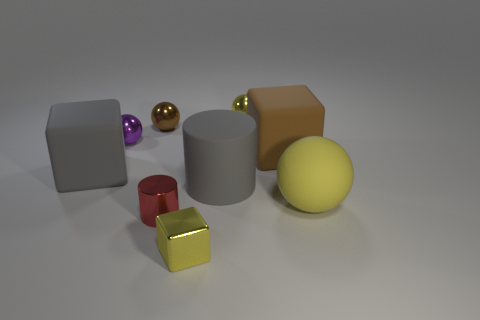Are there any big brown objects left of the small brown shiny ball?
Make the answer very short. No. There is a brown shiny object; what shape is it?
Your answer should be compact. Sphere. The big gray rubber object that is right of the yellow thing that is on the left side of the yellow metal object right of the large cylinder is what shape?
Offer a terse response. Cylinder. How many other objects are the same shape as the small brown thing?
Ensure brevity in your answer.  3. There is a big object that is left of the cylinder in front of the yellow matte sphere; what is its material?
Your response must be concise. Rubber. Is there anything else that has the same size as the brown metallic ball?
Keep it short and to the point. Yes. Is the material of the large gray cylinder the same as the large thing behind the big gray block?
Make the answer very short. Yes. There is a thing that is to the left of the small block and in front of the yellow matte object; what material is it?
Offer a terse response. Metal. The matte block that is to the right of the gray object that is to the right of the small cylinder is what color?
Offer a terse response. Brown. There is a brown cube right of the small red metal cylinder; what material is it?
Your answer should be compact. Rubber. 